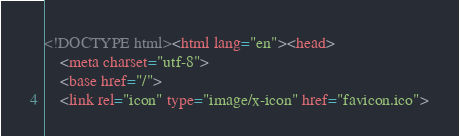<code> <loc_0><loc_0><loc_500><loc_500><_HTML_><!DOCTYPE html><html lang="en"><head>
    <meta charset="utf-8">
    <base href="/">
    <link rel="icon" type="image/x-icon" href="favicon.ico"></code> 